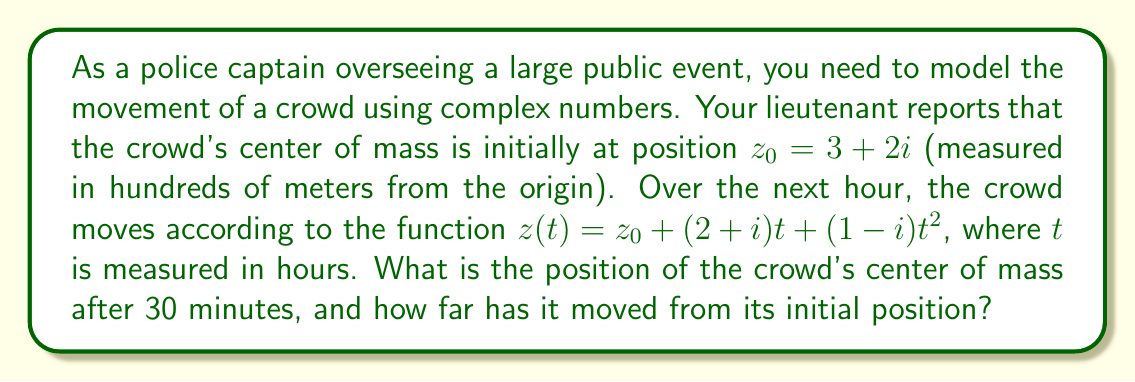Teach me how to tackle this problem. Let's approach this step-by-step:

1) We're given the initial position $z_0 = 3 + 2i$ and the function describing the movement:

   $$z(t) = z_0 + (2+i)t + (1-i)t^2$$

2) We need to find the position after 30 minutes, which is 0.5 hours. So, we'll substitute $t = 0.5$ into the equation:

   $$z(0.5) = (3+2i) + (2+i)(0.5) + (1-i)(0.5)^2$$

3) Let's calculate each term:
   - $(2+i)(0.5) = 1 + 0.5i$
   - $(1-i)(0.5)^2 = (1-i)(0.25) = 0.25 - 0.25i$

4) Now we can add all terms:

   $$z(0.5) = (3+2i) + (1+0.5i) + (0.25-0.25i)$$
   $$= (3+1+0.25) + (2+0.5-0.25)i$$
   $$= 4.25 + 2.25i$$

5) To find how far the crowd has moved, we need to calculate the distance between the initial position and the new position:

   $$\text{Distance} = |z(0.5) - z_0| = |(4.25+2.25i) - (3+2i)|$$
   $$= |(1.25+0.25i)| = \sqrt{1.25^2 + 0.25^2} = \sqrt{1.5625 + 0.0625} = \sqrt{1.625} \approx 1.27$$

6) Remember that our units are in hundreds of meters, so we need to multiply this by 100 to get the actual distance in meters.
Answer: The position of the crowd's center of mass after 30 minutes is $4.25 + 2.25i$ (in hundreds of meters from the origin), and it has moved approximately 127 meters from its initial position. 